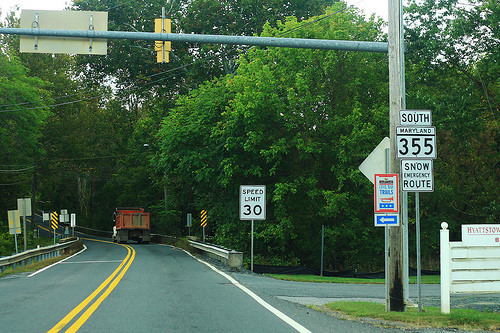<image>
Is there a sign next to the truck? No. The sign is not positioned next to the truck. They are located in different areas of the scene. 